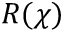<formula> <loc_0><loc_0><loc_500><loc_500>R ( \chi )</formula> 